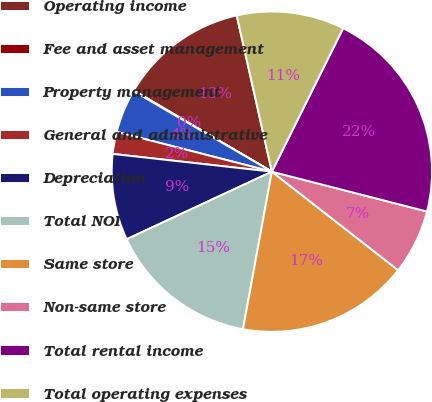Convert chart. <chart><loc_0><loc_0><loc_500><loc_500><pie_chart><fcel>Operating income<fcel>Fee and asset management<fcel>Property management<fcel>General and administrative<fcel>Depreciation<fcel>Total NOI<fcel>Same store<fcel>Non-same store<fcel>Total rental income<fcel>Total operating expenses<nl><fcel>13.02%<fcel>0.07%<fcel>4.39%<fcel>2.23%<fcel>8.7%<fcel>15.18%<fcel>17.34%<fcel>6.54%<fcel>21.66%<fcel>10.86%<nl></chart> 